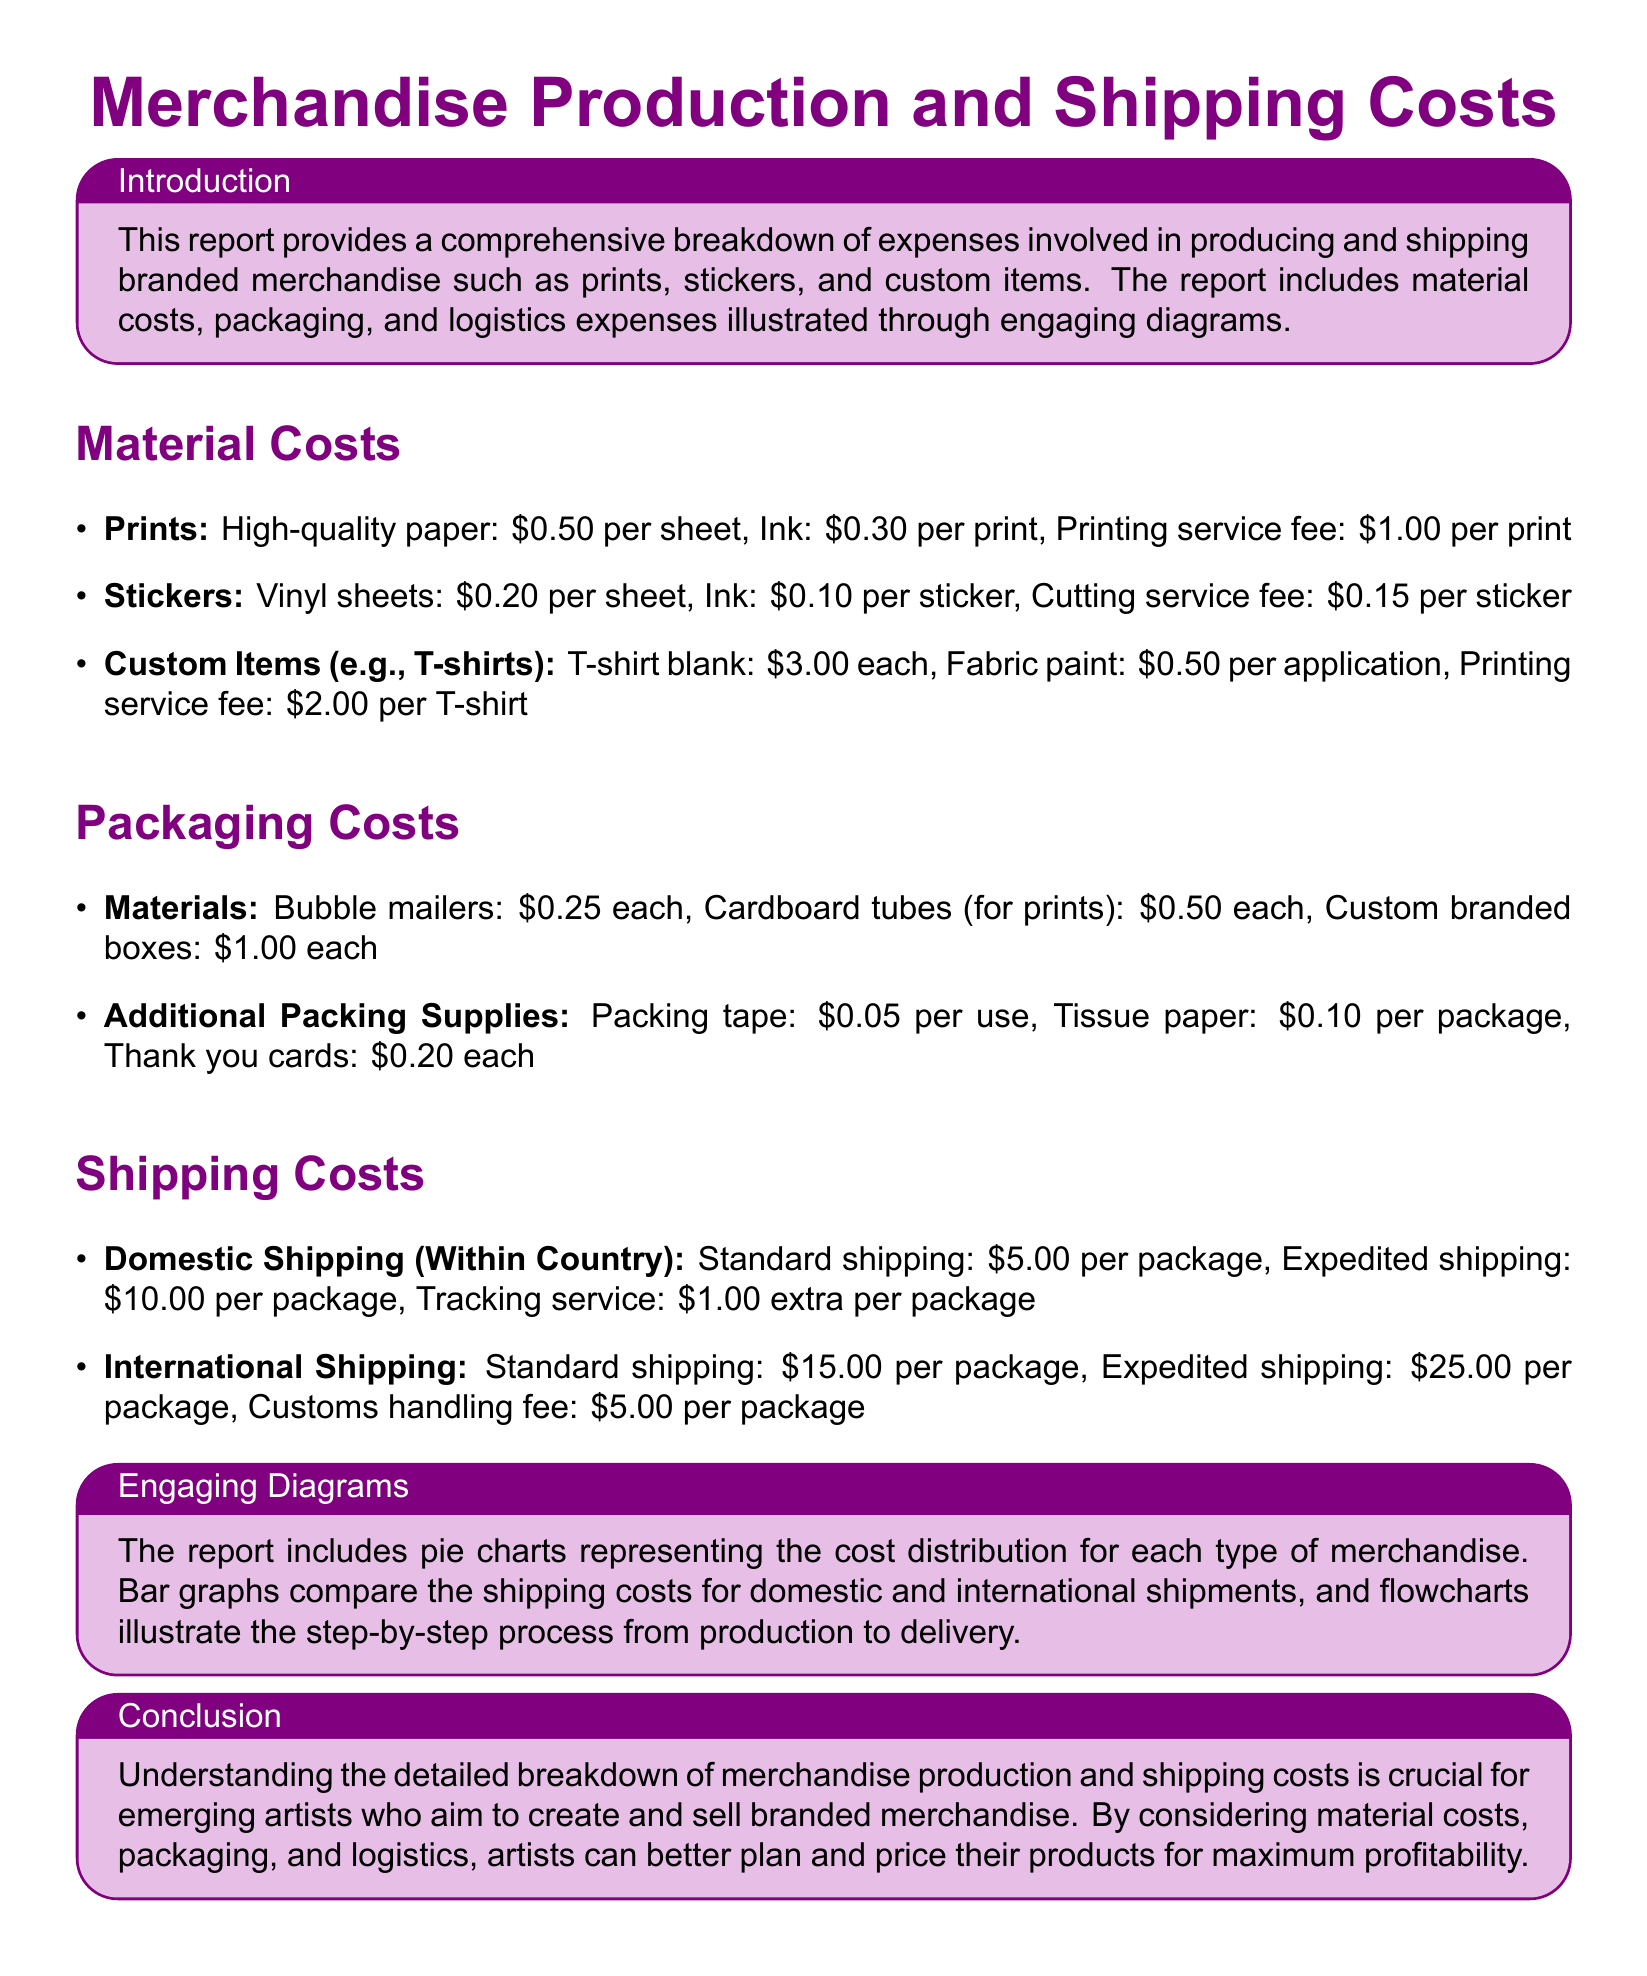What is the cost of high-quality paper for prints? The cost of high-quality paper for prints is listed in the material costs section.
Answer: $0.50 per sheet What are the shipping costs for expedited international shipping? The shipping costs for expedited international shipping is specified under the international shipping section.
Answer: $25.00 per package What is the cost per use of packing tape? The cost per use of packing tape can be found in the packaging costs section.
Answer: $0.05 per use How much is the printing service fee for T-shirts? The printing service fee for T-shirts is mentioned in the material costs for custom items.
Answer: $2.00 per T-shirt What type of visual aids are included in the report? The report includes visual aids that represent cost distribution and comparisons, as described in the engaging diagrams section.
Answer: Pie charts and bar graphs How much does it cost to ship a package domestically? The cost to ship a package domestically is outlined in the shipping costs section.
Answer: $5.00 per package What is the cost of a custom branded box? The cost of a custom branded box is detailed in the packaging costs.
Answer: $1.00 each How much does one thank you card cost? The price of one thank you card is found in the packaging costs section.
Answer: $0.20 each 